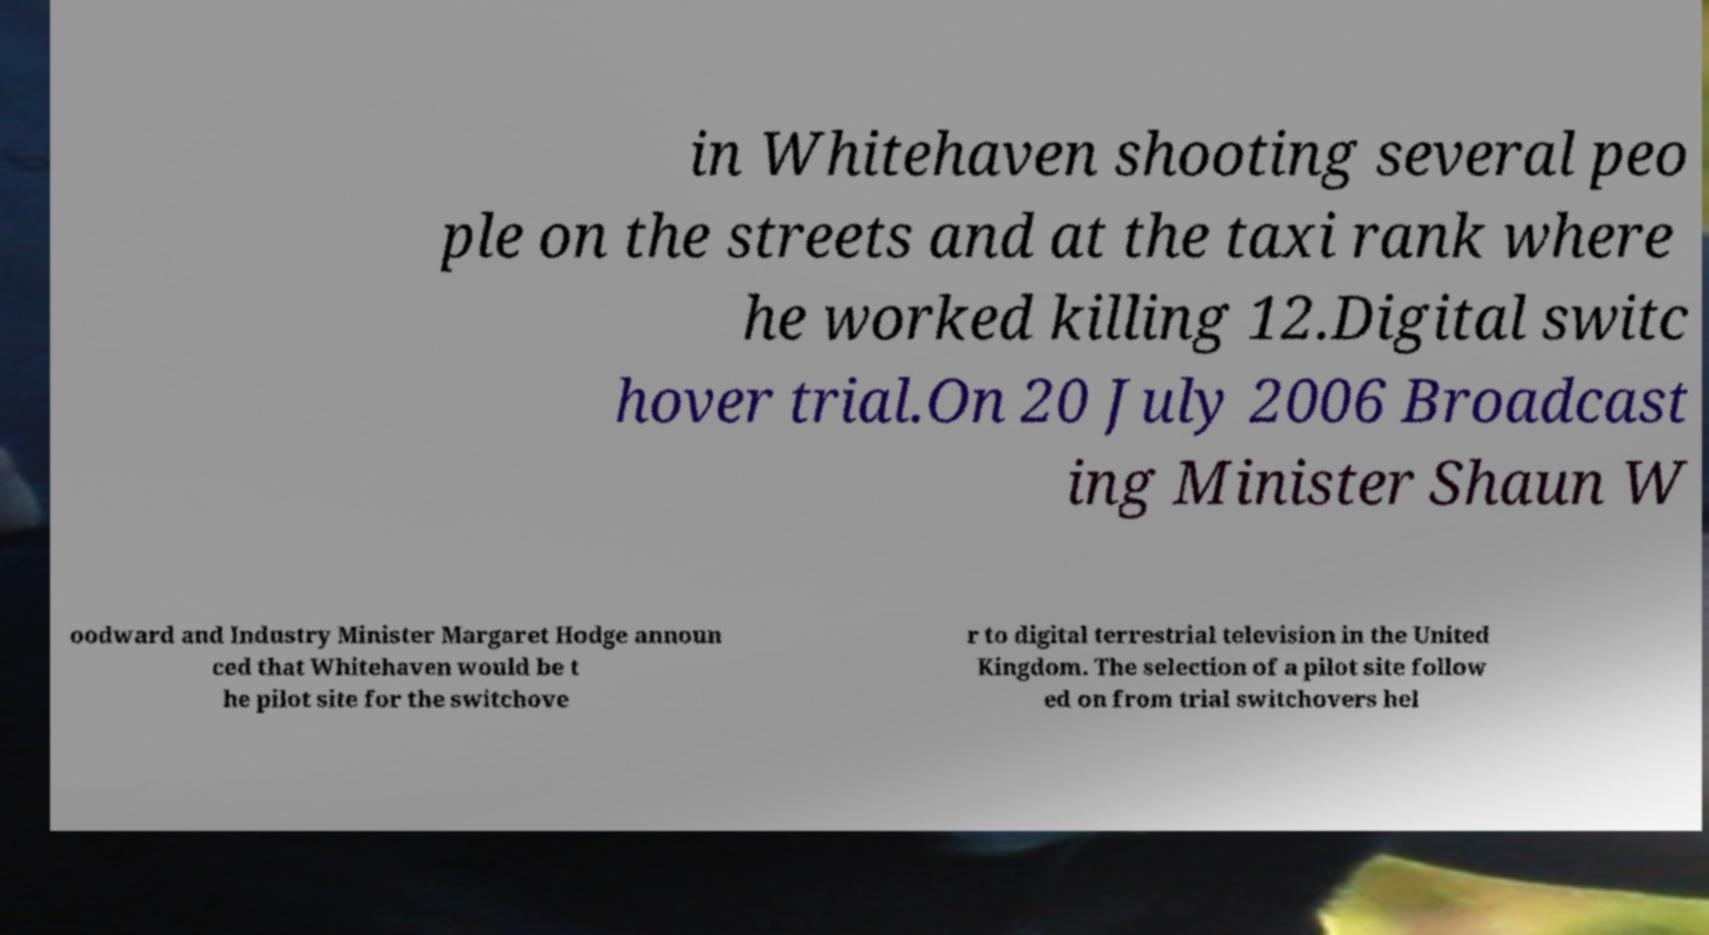Can you accurately transcribe the text from the provided image for me? in Whitehaven shooting several peo ple on the streets and at the taxi rank where he worked killing 12.Digital switc hover trial.On 20 July 2006 Broadcast ing Minister Shaun W oodward and Industry Minister Margaret Hodge announ ced that Whitehaven would be t he pilot site for the switchove r to digital terrestrial television in the United Kingdom. The selection of a pilot site follow ed on from trial switchovers hel 